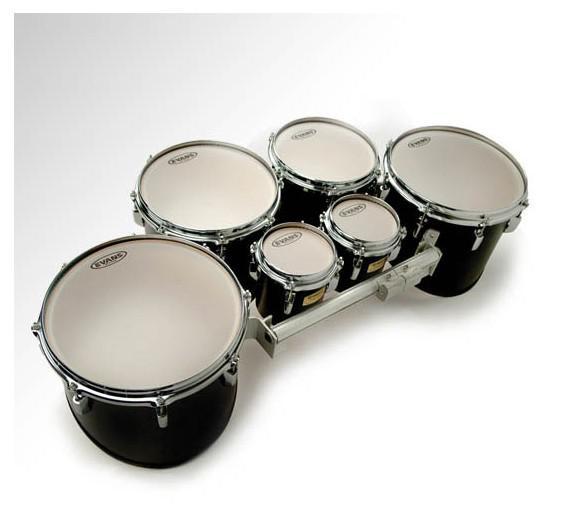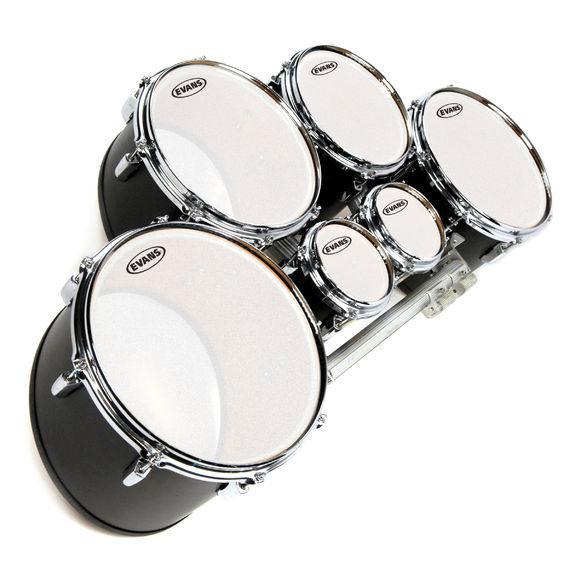The first image is the image on the left, the second image is the image on the right. For the images displayed, is the sentence "At least one kit contains more than four drums." factually correct? Answer yes or no. Yes. The first image is the image on the left, the second image is the image on the right. Assess this claim about the two images: "The drum base is white in the left image.". Correct or not? Answer yes or no. No. 